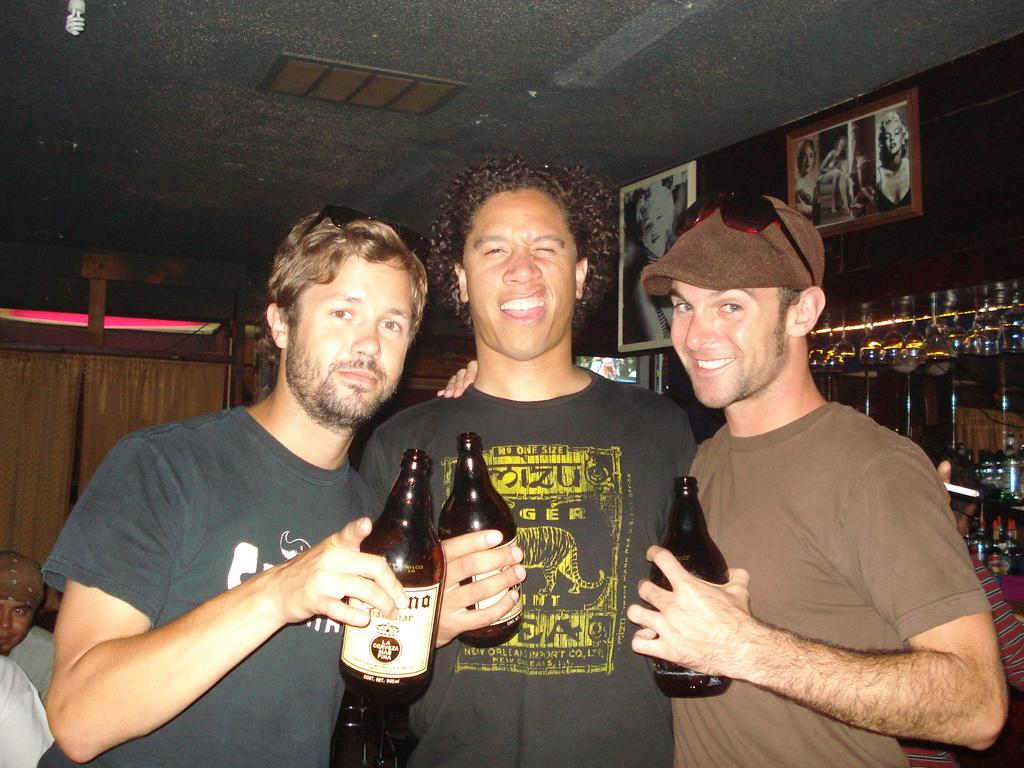How many people are present in the image? There are three persons standing in the image. What are the persons holding in their hands? The persons are holding bottles in their hands. What can be seen in the background of the image? There are glasses, photo frames on the wall, and curtains in the background of the image. What type of ice is being served in the image? There is no ice present in the image; the persons are holding bottles. What kind of yam dish is being prepared in the image? There is no yam dish or any cooking activity depicted in the image. 